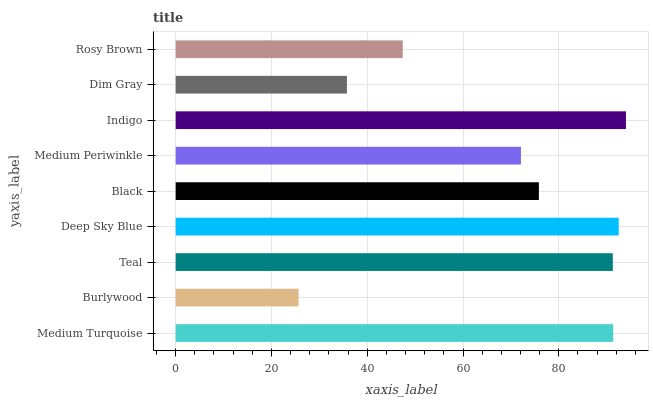Is Burlywood the minimum?
Answer yes or no. Yes. Is Indigo the maximum?
Answer yes or no. Yes. Is Teal the minimum?
Answer yes or no. No. Is Teal the maximum?
Answer yes or no. No. Is Teal greater than Burlywood?
Answer yes or no. Yes. Is Burlywood less than Teal?
Answer yes or no. Yes. Is Burlywood greater than Teal?
Answer yes or no. No. Is Teal less than Burlywood?
Answer yes or no. No. Is Black the high median?
Answer yes or no. Yes. Is Black the low median?
Answer yes or no. Yes. Is Rosy Brown the high median?
Answer yes or no. No. Is Burlywood the low median?
Answer yes or no. No. 